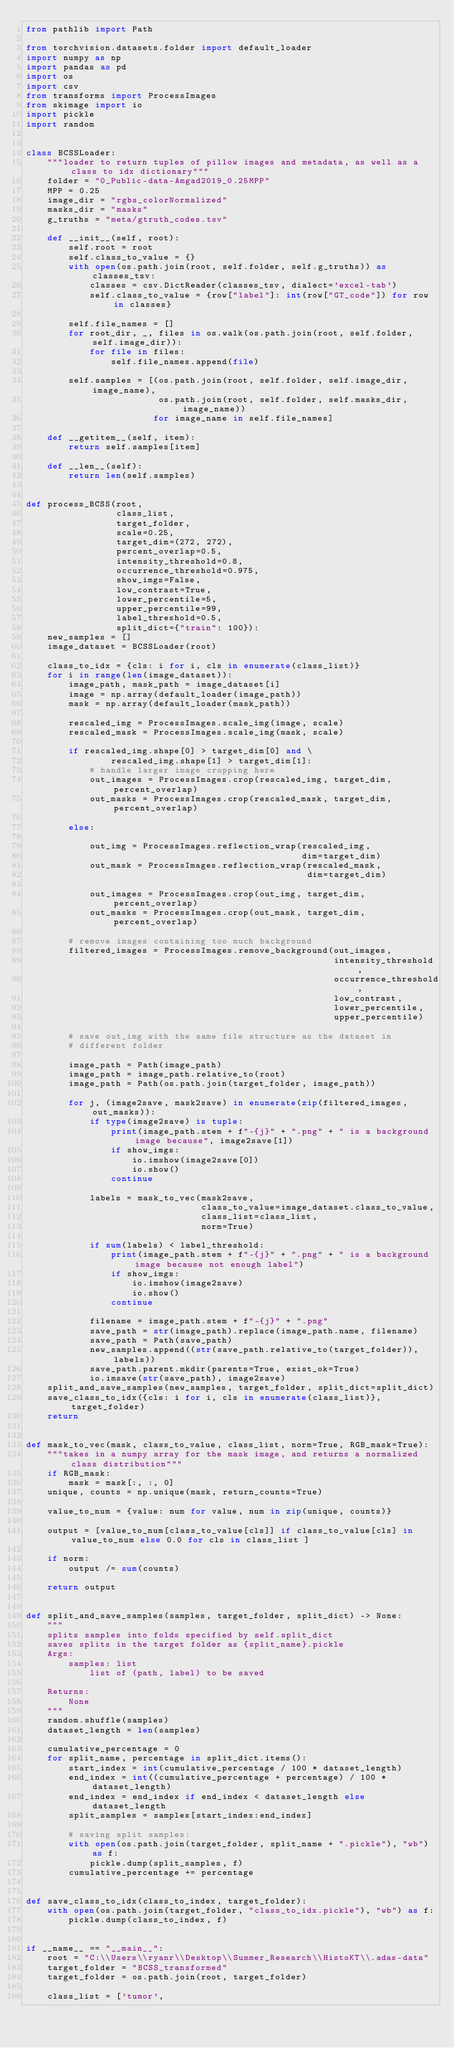<code> <loc_0><loc_0><loc_500><loc_500><_Python_>from pathlib import Path

from torchvision.datasets.folder import default_loader
import numpy as np
import pandas as pd
import os
import csv
from transforms import ProcessImages
from skimage import io
import pickle
import random


class BCSSLoader:
    """loader to return tuples of pillow images and metadata, as well as a class to idx dictionary"""
    folder = "0_Public-data-Amgad2019_0.25MPP"
    MPP = 0.25
    image_dir = "rgbs_colorNormalized"
    masks_dir = "masks"
    g_truths = "meta/gtruth_codes.tsv"

    def __init__(self, root):
        self.root = root
        self.class_to_value = {}
        with open(os.path.join(root, self.folder, self.g_truths)) as classes_tsv:
            classes = csv.DictReader(classes_tsv, dialect='excel-tab')
            self.class_to_value = {row["label"]: int(row["GT_code"]) for row in classes}

        self.file_names = []
        for root_dir, _, files in os.walk(os.path.join(root, self.folder, self.image_dir)):
            for file in files:
                self.file_names.append(file)

        self.samples = [(os.path.join(root, self.folder, self.image_dir, image_name),
                         os.path.join(root, self.folder, self.masks_dir, image_name))
                        for image_name in self.file_names]

    def __getitem__(self, item):
        return self.samples[item]

    def __len__(self):
        return len(self.samples)


def process_BCSS(root,
                 class_list,
                 target_folder,
                 scale=0.25,
                 target_dim=(272, 272),
                 percent_overlap=0.5,
                 intensity_threshold=0.8,
                 occurrence_threshold=0.975,
                 show_imgs=False,
                 low_contrast=True,
                 lower_percentile=5,
                 upper_percentile=99,
                 label_threshold=0.5,
                 split_dict={"train": 100}):
    new_samples = []
    image_dataset = BCSSLoader(root)

    class_to_idx = {cls: i for i, cls in enumerate(class_list)}
    for i in range(len(image_dataset)):
        image_path, mask_path = image_dataset[i]
        image = np.array(default_loader(image_path))
        mask = np.array(default_loader(mask_path))

        rescaled_img = ProcessImages.scale_img(image, scale)
        rescaled_mask = ProcessImages.scale_img(mask, scale)

        if rescaled_img.shape[0] > target_dim[0] and \
                rescaled_img.shape[1] > target_dim[1]:
            # handle larger image cropping here
            out_images = ProcessImages.crop(rescaled_img, target_dim, percent_overlap)
            out_masks = ProcessImages.crop(rescaled_mask, target_dim, percent_overlap)

        else:

            out_img = ProcessImages.reflection_wrap(rescaled_img,
                                                    dim=target_dim)
            out_mask = ProcessImages.reflection_wrap(rescaled_mask,
                                                     dim=target_dim)

            out_images = ProcessImages.crop(out_img, target_dim, percent_overlap)
            out_masks = ProcessImages.crop(out_mask, target_dim, percent_overlap)

        # remove images containing too much background
        filtered_images = ProcessImages.remove_background(out_images,
                                                          intensity_threshold,
                                                          occurrence_threshold,
                                                          low_contrast,
                                                          lower_percentile,
                                                          upper_percentile)

        # save out_img with the same file structure as the dataset in
        # different folder

        image_path = Path(image_path)
        image_path = image_path.relative_to(root)
        image_path = Path(os.path.join(target_folder, image_path))

        for j, (image2save, mask2save) in enumerate(zip(filtered_images, out_masks)):
            if type(image2save) is tuple:
                print(image_path.stem + f"-{j}" + ".png" + " is a background image because", image2save[1])
                if show_imgs:
                    io.imshow(image2save[0])
                    io.show()
                continue

            labels = mask_to_vec(mask2save,
                                 class_to_value=image_dataset.class_to_value,
                                 class_list=class_list,
                                 norm=True)

            if sum(labels) < label_threshold:
                print(image_path.stem + f"-{j}" + ".png" + " is a background image because not enough label")
                if show_imgs:
                    io.imshow(image2save)
                    io.show()
                continue

            filename = image_path.stem + f"-{j}" + ".png"
            save_path = str(image_path).replace(image_path.name, filename)
            save_path = Path(save_path)
            new_samples.append((str(save_path.relative_to(target_folder)), labels))
            save_path.parent.mkdir(parents=True, exist_ok=True)
            io.imsave(str(save_path), image2save)
    split_and_save_samples(new_samples, target_folder, split_dict=split_dict)
    save_class_to_idx({cls: i for i, cls in enumerate(class_list)}, target_folder)
    return


def mask_to_vec(mask, class_to_value, class_list, norm=True, RGB_mask=True):
    """takes in a numpy array for the mask image, and returns a normalized class distribution"""
    if RGB_mask:
        mask = mask[:, :, 0]
    unique, counts = np.unique(mask, return_counts=True)

    value_to_num = {value: num for value, num in zip(unique, counts)}

    output = [value_to_num[class_to_value[cls]] if class_to_value[cls] in value_to_num else 0.0 for cls in class_list ]

    if norm:
        output /= sum(counts)

    return output


def split_and_save_samples(samples, target_folder, split_dict) -> None:
    """
    splits samples into folds specified by self.split_dict
    saves splits in the target folder as {split_name}.pickle
    Args:
        samples: list
            list of (path, label) to be saved

    Returns:
        None
    """
    random.shuffle(samples)
    dataset_length = len(samples)

    cumulative_percentage = 0
    for split_name, percentage in split_dict.items():
        start_index = int(cumulative_percentage / 100 * dataset_length)
        end_index = int((cumulative_percentage + percentage) / 100 * dataset_length)
        end_index = end_index if end_index < dataset_length else dataset_length
        split_samples = samples[start_index:end_index]

        # saving split samples:
        with open(os.path.join(target_folder, split_name + ".pickle"), "wb") as f:
            pickle.dump(split_samples, f)
        cumulative_percentage += percentage


def save_class_to_idx(class_to_index, target_folder):
    with open(os.path.join(target_folder, "class_to_idx.pickle"), "wb") as f:
        pickle.dump(class_to_index, f)


if __name__ == "__main__":
    root = "C:\\Users\\ryanr\\Desktop\\Summer_Research\\HistoKT\\.adas-data"
    target_folder = "BCSS_transformed"
    target_folder = os.path.join(root, target_folder)

    class_list = ['tumor',</code> 